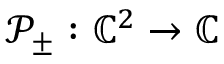<formula> <loc_0><loc_0><loc_500><loc_500>\mathcal { P } _ { \pm } \colon \mathbb { C } ^ { 2 } \rightarrow \mathbb { C }</formula> 